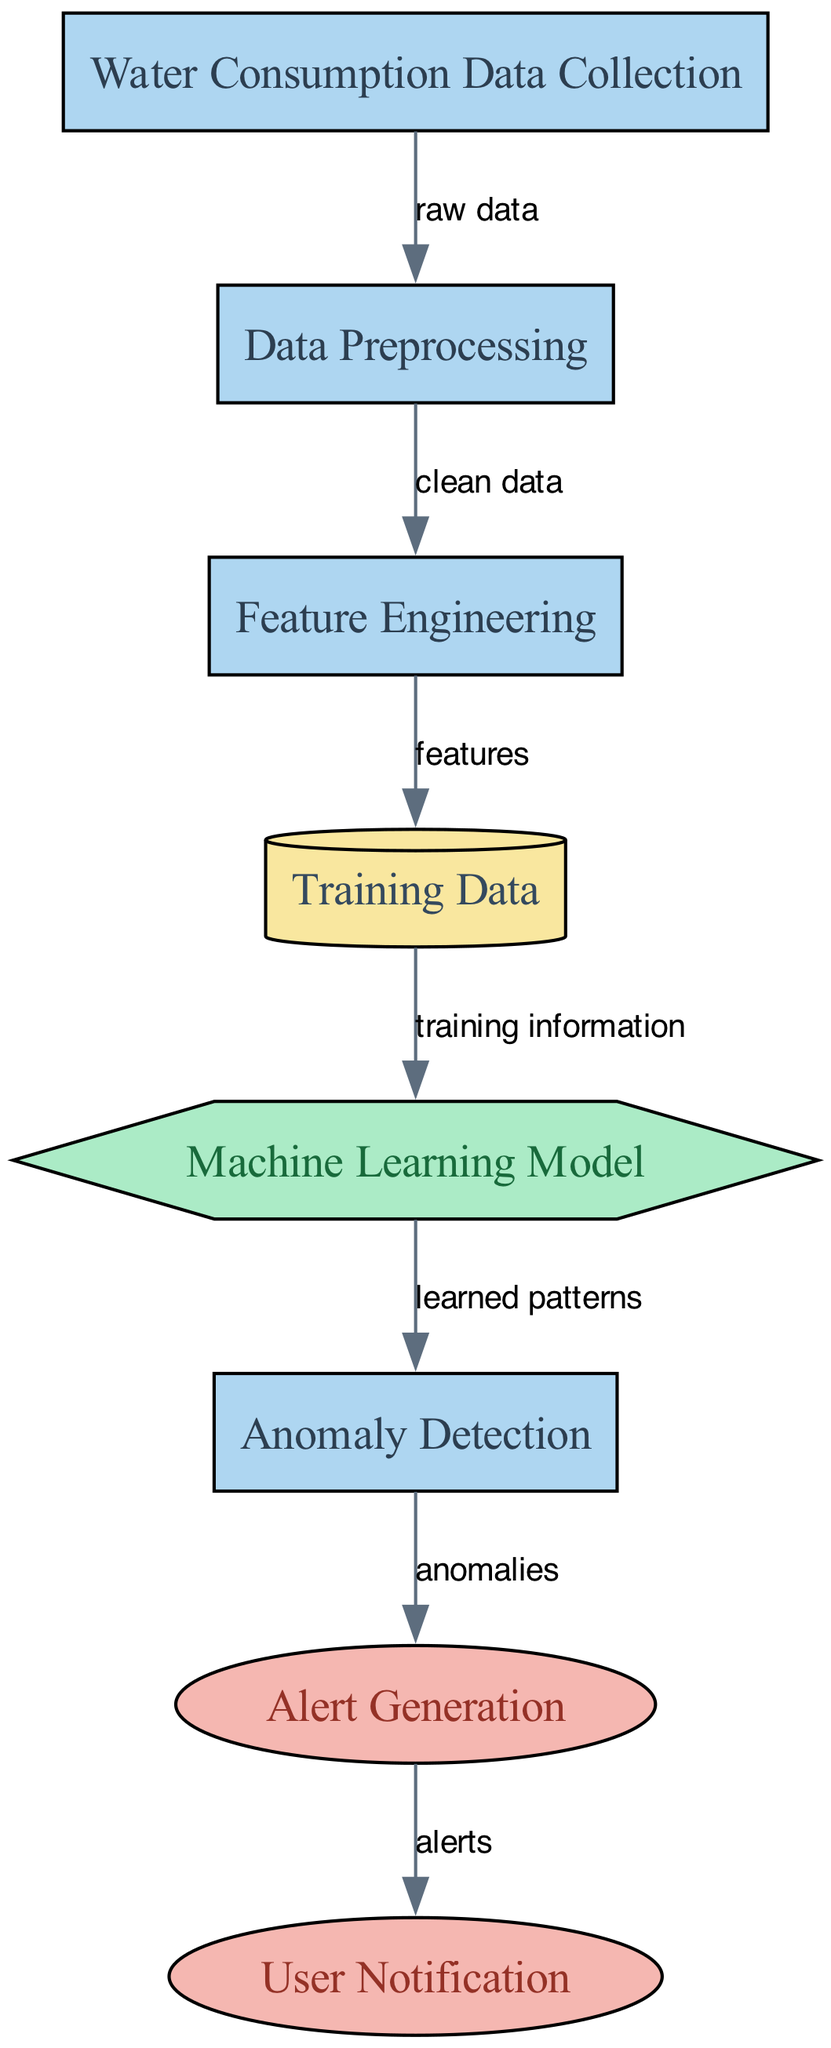What is the first step in the process? The diagram indicates that the first step is "Water Consumption Data Collection," which involves collecting data from households' smart meters.
Answer: Water Consumption Data Collection How many nodes are present in the diagram? By counting the nodes listed in the diagram, there are a total of 8 nodes representing various processes, data, models, and outputs.
Answer: 8 Which node represents the machine learning model? The node labeled "Machine Learning Model" specifically represents the model that trains on normal consumption patterns, identified by its unique label.
Answer: Machine Learning Model What type is the node labeled "Data Preprocessing"? The node "Data Preprocessing" is categorized as a process, as indicated in its type description in the diagram.
Answer: process What connects "Training Data" and "Machine Learning Model"? The edge labeled "training information" connects the "Training Data" node to the "Machine Learning Model" node, indicating that historical patterns are used for training.
Answer: training information In what stage are anomalies detected? Anomalies are detected in the "Anomaly Detection" stage, which follows the training of the model on normal consumption patterns.
Answer: Anomaly Detection What is generated after identifying anomalies? "Alert Generation" follows the "Anomaly Detection" process and involves generating alerts for the detected anomalies in water usage.
Answer: Alert Generation Which output node notifies residents? The output node labeled "User Notification" indicates the step where residents are notified about unusual water usage detected by the system.
Answer: User Notification What is the input to the "Feature Engineering" process? The input to the "Feature Engineering" process is "clean data," which is the output from the "Data Preprocessing" step.
Answer: clean data 